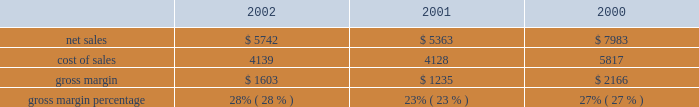In a new business model such as the retail segment is inherently risky , particularly in light of the significant investment involved , the current economic climate , and the fixed nature of a substantial portion of the retail segment's operating expenses .
Results for this segment are dependent upon a number of risks and uncertainties , some of which are discussed below under the heading "factors that may affect future results and financial condition." backlog in the company's experience , the actual amount of product backlog at any particular time is not a meaningful indication of its future business prospects .
In particular , backlog often increases in anticipation of or immediately following new product introductions because of over- ordering by dealers anticipating shortages .
Backlog often is reduced once dealers and customers believe they can obtain sufficient supply .
Because of the foregoing , backlog cannot be considered a reliable indicator of the company's ability to achieve any particular level of revenue or financial performance .
Further information regarding the company's backlog may be found below under the heading "factors that may affect future results and financial condition." gross margin gross margin for the three fiscal years ended september 28 , 2002 are as follows ( in millions , except gross margin percentages ) : gross margin increased to 28% ( 28 % ) of net sales in 2002 from 23% ( 23 % ) in 2001 .
As discussed below , gross margin in 2001 was unusually low resulting from negative gross margin of 2% ( 2 % ) experienced in the first quarter of 2001 .
As a percentage of net sales , the company's quarterly gross margins declined during fiscal 2002 from 31% ( 31 % ) in the first quarter down to 26% ( 26 % ) in the fourth quarter .
This decline resulted from several factors including a rise in component costs as the year progressed and aggressive pricing by the company across its products lines instituted as a result of continued pricing pressures in the personal computer industry .
The company anticipates that its gross margin and the gross margin of the overall personal computer industry will remain under pressure throughout fiscal 2003 in light of weak economic conditions , flat demand for personal computers in general , and the resulting pressure on prices .
The foregoing statements regarding anticipated gross margin in 2003 and the general demand for personal computers during 2003 are forward- looking .
Gross margin could differ from anticipated levels because of several factors , including certain of those set forth below in the subsection entitled "factors that may affect future results and financial condition." there can be no assurance that current gross margins will be maintained , targeted gross margin levels will be achieved , or current margins on existing individual products will be maintained .
In general , gross margins and margins on individual products will remain under significant downward pressure due to a variety of factors , including continued industry wide global pricing pressures , increased competition , compressed product life cycles , potential increases in the cost and availability of raw material and outside manufacturing services , and potential changes to the company's product mix , including higher unit sales of consumer products with lower average selling prices and lower gross margins .
In response to these downward pressures , the company expects it will continue to take pricing actions with respect to its products .
Gross margins could also be affected by the company's ability to effectively manage quality problems and warranty costs and to stimulate demand for certain of its products .
The company's operating strategy and pricing take into account anticipated changes in foreign currency exchange rates over time ; however , the company's results of operations can be significantly affected in the short-term by fluctuations in exchange rates .
The company orders components for its products and builds inventory in advance of product shipments .
Because the company's markets are volatile and subject to rapid technology and price changes , there is a risk the company will forecast incorrectly and produce or order from third parties excess or insufficient inventories of particular products or components .
The company's operating results and financial condition have been in the past and may in the future be materially adversely affected by the company's ability to manage its inventory levels and outstanding purchase commitments and to respond to short-term shifts in customer demand patterns .
Gross margin declined to 23% ( 23 % ) of net sales in 2001 from 27% ( 27 % ) in 2000 .
This decline resulted primarily from gross margin of negative 2% ( 2 % ) experienced during the first quarter of 2001 compared to 26% ( 26 % ) gross margin for the same quarter in 2000 .
In addition to lower than normal net .

What was the percentage change in net sales from 2001 to 2002? 
Computations: ((5742 - 5363) / 5363)
Answer: 0.07067. 